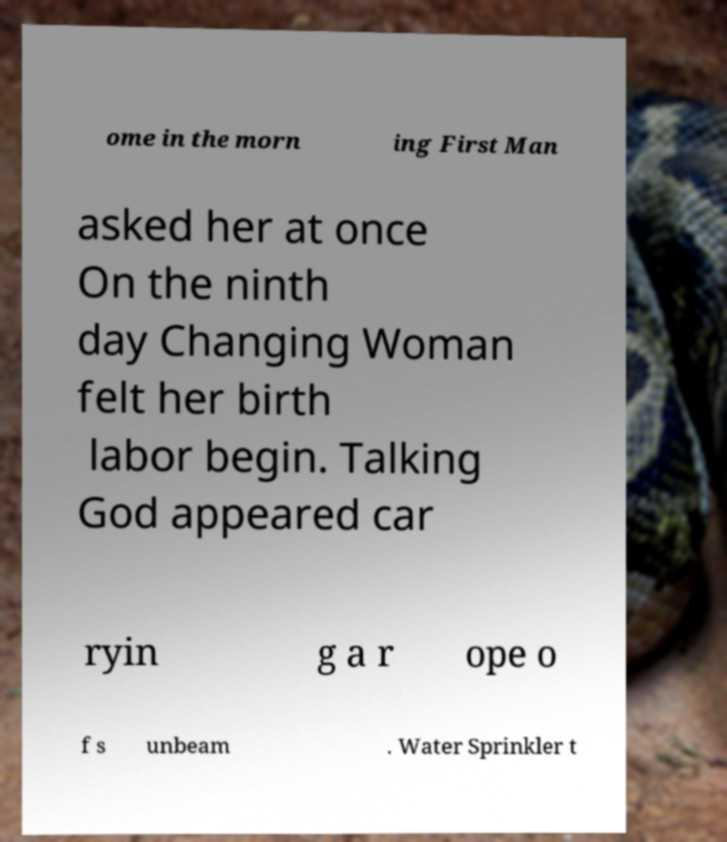For documentation purposes, I need the text within this image transcribed. Could you provide that? ome in the morn ing First Man asked her at once On the ninth day Changing Woman felt her birth labor begin. Talking God appeared car ryin g a r ope o f s unbeam . Water Sprinkler t 